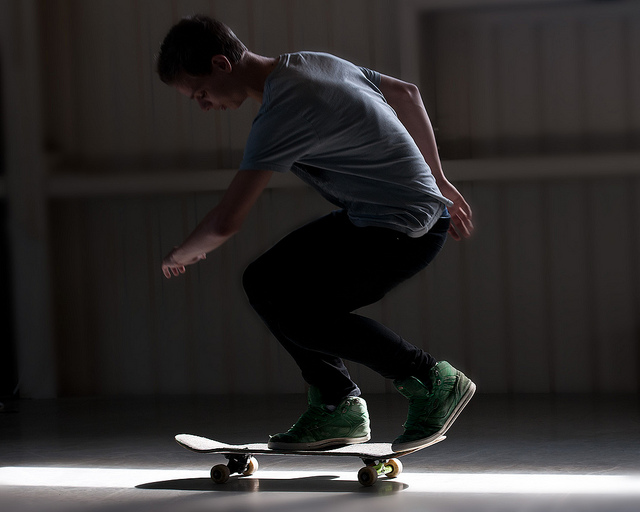<image>Is the sport fun? It depends on personal preference, some may find the sport fun and others may not. Is the sport fun? It depends whether the sport is fun or not. Some people might find it fun, while others might not. 